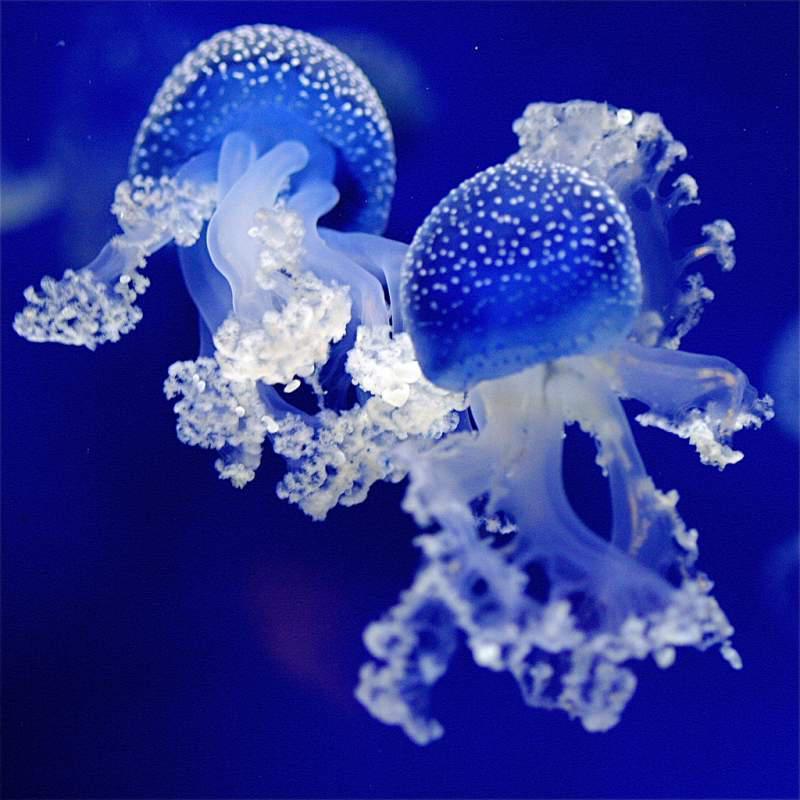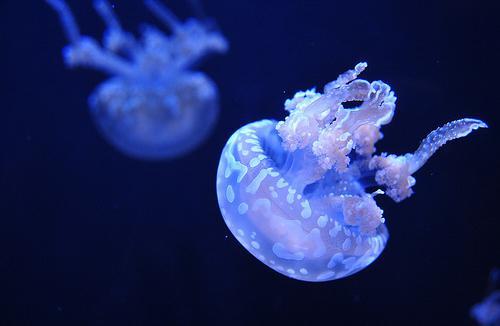The first image is the image on the left, the second image is the image on the right. Examine the images to the left and right. Is the description "In one of the images, a single jellyfish floats on its side" accurate? Answer yes or no. No. The first image is the image on the left, the second image is the image on the right. Examine the images to the left and right. Is the description "An image shows just one jellyfish, which has long, non-curly tendrils." accurate? Answer yes or no. No. 